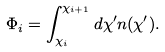<formula> <loc_0><loc_0><loc_500><loc_500>\Phi _ { i } = \int _ { \chi _ { i } } ^ { \chi _ { i + 1 } } d \chi ^ { \prime } n ( \chi ^ { \prime } ) .</formula> 